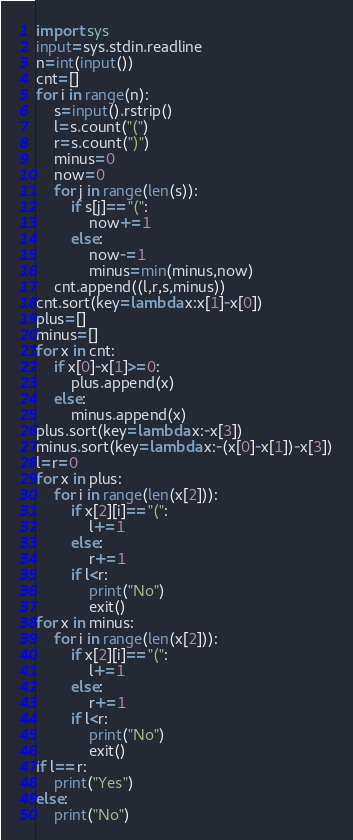<code> <loc_0><loc_0><loc_500><loc_500><_Python_>import sys
input=sys.stdin.readline
n=int(input())
cnt=[]
for i in range(n):
	s=input().rstrip()
	l=s.count("(")
	r=s.count(")")
	minus=0
	now=0
	for j in range(len(s)):
		if s[j]=="(":
			now+=1
		else:
			now-=1
			minus=min(minus,now)
	cnt.append((l,r,s,minus))
cnt.sort(key=lambda x:x[1]-x[0])
plus=[]
minus=[]
for x in cnt:
	if x[0]-x[1]>=0:
		plus.append(x)
	else:
		minus.append(x)
plus.sort(key=lambda x:-x[3])
minus.sort(key=lambda x:-(x[0]-x[1])-x[3])
l=r=0
for x in plus:
	for i in range(len(x[2])):
		if x[2][i]=="(":
			l+=1
		else:
			r+=1
		if l<r:
			print("No")
			exit()
for x in minus:
	for i in range(len(x[2])):
		if x[2][i]=="(":
			l+=1
		else:
			r+=1
		if l<r:
			print("No")
			exit()
if l==r:
	print("Yes")
else:
	print("No")
</code> 